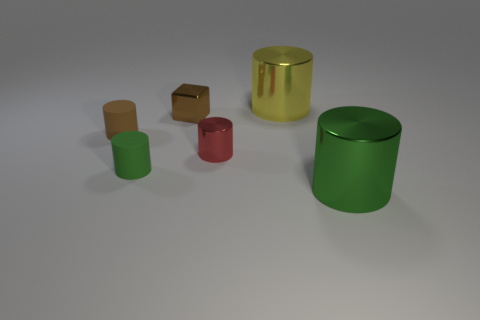The small metallic cylinder has what color?
Your answer should be very brief. Red. What number of things are big metallic objects or tiny green cylinders?
Your response must be concise. 3. There is a tiny brown object that is on the left side of the green cylinder that is left of the large yellow object; what is its shape?
Offer a very short reply. Cylinder. What number of other objects are the same material as the tiny green cylinder?
Keep it short and to the point. 1. Does the small brown block have the same material as the green cylinder to the left of the large yellow shiny cylinder?
Your answer should be compact. No. How many things are small cylinders that are behind the red shiny object or tiny metal objects that are in front of the small brown metal cube?
Make the answer very short. 2. How many other objects are the same color as the cube?
Your answer should be compact. 1. Is the number of brown shiny things to the right of the tiny brown cylinder greater than the number of red metallic things on the left side of the tiny metallic cylinder?
Your answer should be compact. Yes. Are there any other things that have the same size as the yellow metallic thing?
Keep it short and to the point. Yes. How many cylinders are large yellow shiny objects or big green things?
Your answer should be very brief. 2. 